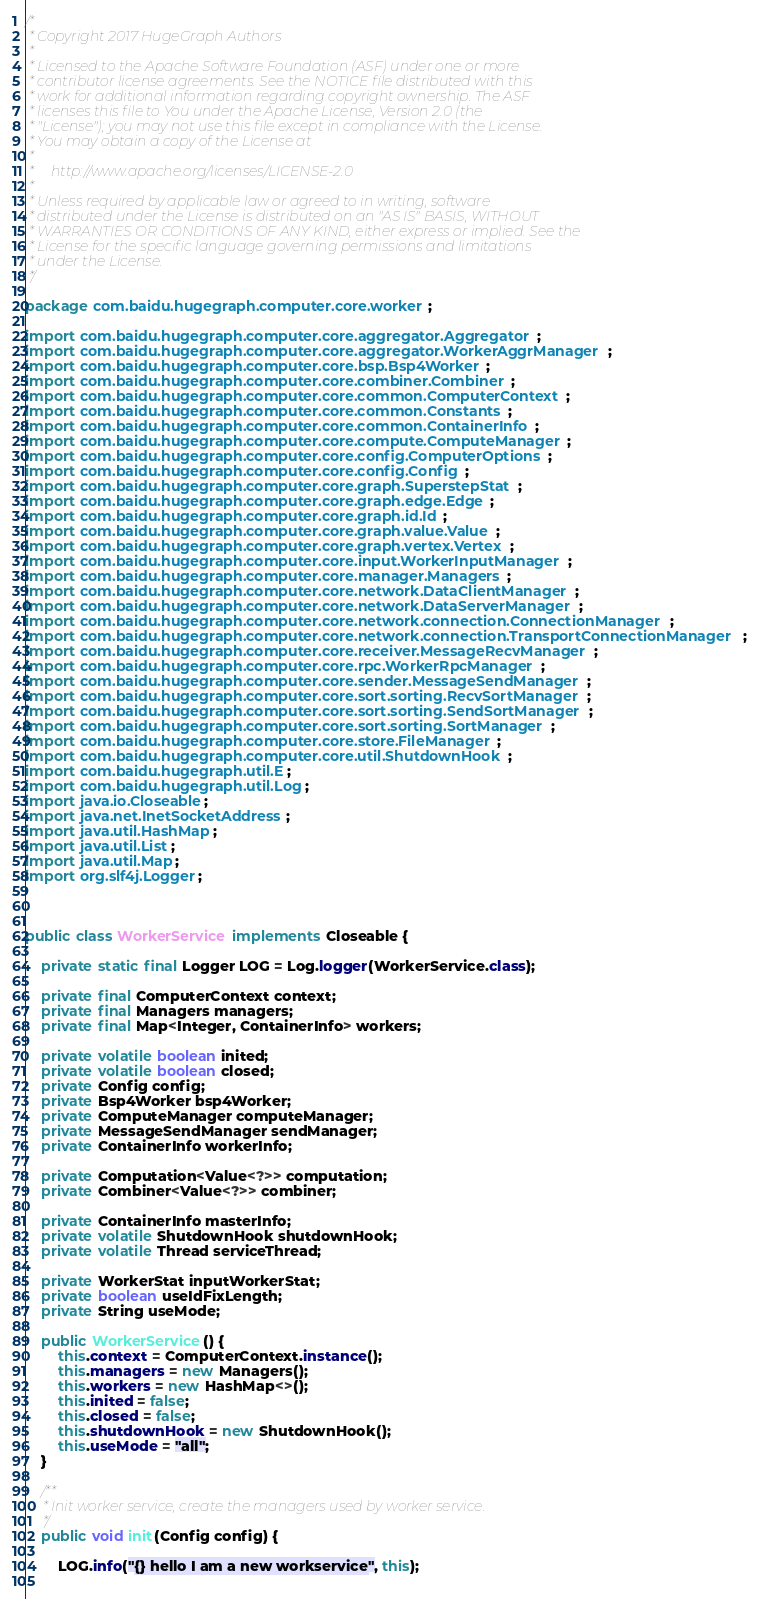<code> <loc_0><loc_0><loc_500><loc_500><_Java_>/*
 * Copyright 2017 HugeGraph Authors
 *
 * Licensed to the Apache Software Foundation (ASF) under one or more
 * contributor license agreements. See the NOTICE file distributed with this
 * work for additional information regarding copyright ownership. The ASF
 * licenses this file to You under the Apache License, Version 2.0 (the
 * "License"); you may not use this file except in compliance with the License.
 * You may obtain a copy of the License at
 *
 *     http://www.apache.org/licenses/LICENSE-2.0
 *
 * Unless required by applicable law or agreed to in writing, software
 * distributed under the License is distributed on an "AS IS" BASIS, WITHOUT
 * WARRANTIES OR CONDITIONS OF ANY KIND, either express or implied. See the
 * License for the specific language governing permissions and limitations
 * under the License.
 */

package com.baidu.hugegraph.computer.core.worker;

import com.baidu.hugegraph.computer.core.aggregator.Aggregator;
import com.baidu.hugegraph.computer.core.aggregator.WorkerAggrManager;
import com.baidu.hugegraph.computer.core.bsp.Bsp4Worker;
import com.baidu.hugegraph.computer.core.combiner.Combiner;
import com.baidu.hugegraph.computer.core.common.ComputerContext;
import com.baidu.hugegraph.computer.core.common.Constants;
import com.baidu.hugegraph.computer.core.common.ContainerInfo;
import com.baidu.hugegraph.computer.core.compute.ComputeManager;
import com.baidu.hugegraph.computer.core.config.ComputerOptions;
import com.baidu.hugegraph.computer.core.config.Config;
import com.baidu.hugegraph.computer.core.graph.SuperstepStat;
import com.baidu.hugegraph.computer.core.graph.edge.Edge;
import com.baidu.hugegraph.computer.core.graph.id.Id;
import com.baidu.hugegraph.computer.core.graph.value.Value;
import com.baidu.hugegraph.computer.core.graph.vertex.Vertex;
import com.baidu.hugegraph.computer.core.input.WorkerInputManager;
import com.baidu.hugegraph.computer.core.manager.Managers;
import com.baidu.hugegraph.computer.core.network.DataClientManager;
import com.baidu.hugegraph.computer.core.network.DataServerManager;
import com.baidu.hugegraph.computer.core.network.connection.ConnectionManager;
import com.baidu.hugegraph.computer.core.network.connection.TransportConnectionManager;
import com.baidu.hugegraph.computer.core.receiver.MessageRecvManager;
import com.baidu.hugegraph.computer.core.rpc.WorkerRpcManager;
import com.baidu.hugegraph.computer.core.sender.MessageSendManager;
import com.baidu.hugegraph.computer.core.sort.sorting.RecvSortManager;
import com.baidu.hugegraph.computer.core.sort.sorting.SendSortManager;
import com.baidu.hugegraph.computer.core.sort.sorting.SortManager;
import com.baidu.hugegraph.computer.core.store.FileManager;
import com.baidu.hugegraph.computer.core.util.ShutdownHook;
import com.baidu.hugegraph.util.E;
import com.baidu.hugegraph.util.Log;
import java.io.Closeable;
import java.net.InetSocketAddress;
import java.util.HashMap;
import java.util.List;
import java.util.Map;
import org.slf4j.Logger;



public class WorkerService implements Closeable {

    private static final Logger LOG = Log.logger(WorkerService.class);

    private final ComputerContext context;
    private final Managers managers;
    private final Map<Integer, ContainerInfo> workers;

    private volatile boolean inited;
    private volatile boolean closed;
    private Config config;
    private Bsp4Worker bsp4Worker;
    private ComputeManager computeManager;
    private MessageSendManager sendManager;
    private ContainerInfo workerInfo;

    private Computation<Value<?>> computation;
    private Combiner<Value<?>> combiner;

    private ContainerInfo masterInfo;
    private volatile ShutdownHook shutdownHook;
    private volatile Thread serviceThread;

    private WorkerStat inputWorkerStat;
    private boolean useIdFixLength;
    private String useMode;

    public WorkerService() {
        this.context = ComputerContext.instance();
        this.managers = new Managers();
        this.workers = new HashMap<>();
        this.inited = false;
        this.closed = false;
        this.shutdownHook = new ShutdownHook();
        this.useMode = "all";
    }

    /**
     * Init worker service, create the managers used by worker service.
     */
    public void init(Config config) {

        LOG.info("{} hello I am a new workservice", this);
        </code> 